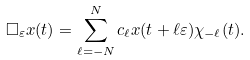<formula> <loc_0><loc_0><loc_500><loc_500>\Box _ { \varepsilon } x ( t ) = \sum _ { \ell = - N } ^ { N } c _ { \ell } x ( t + \ell \varepsilon ) \chi _ { - \ell } ( t ) .</formula> 